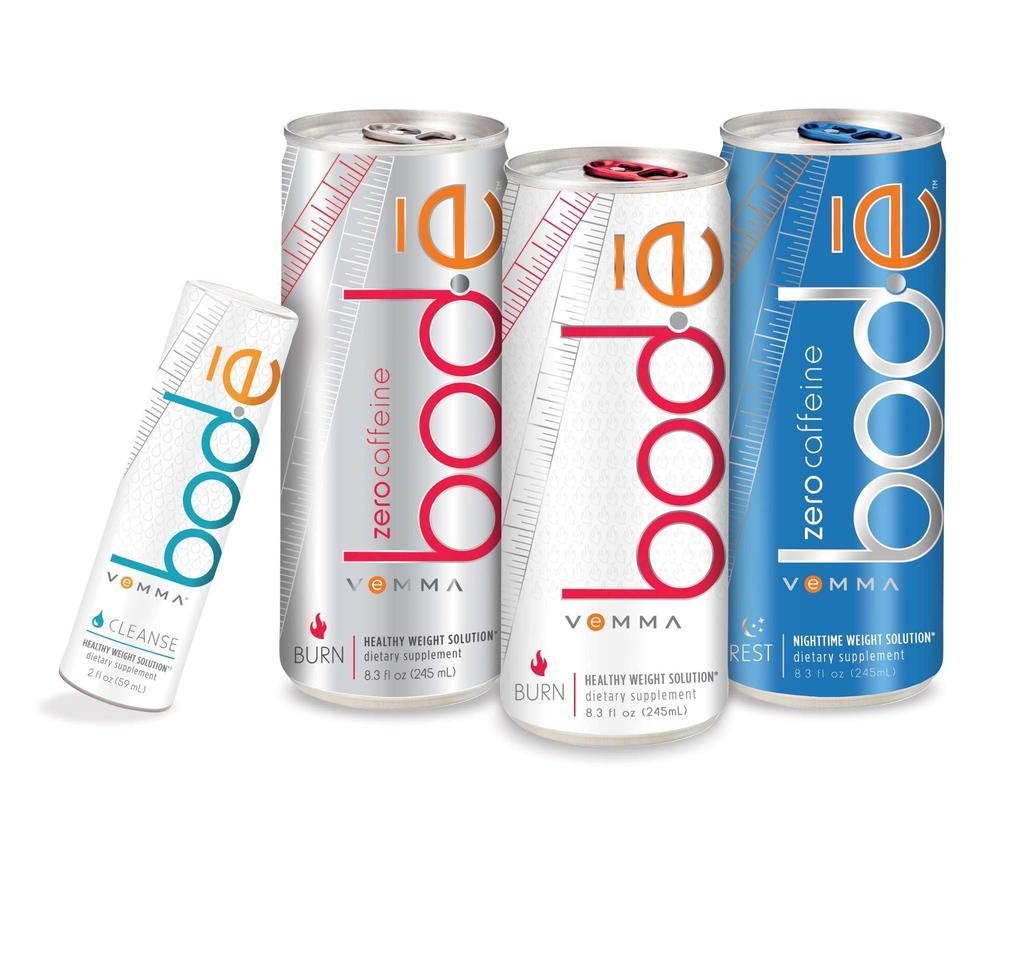<image>
Describe the image concisely. a bode can that is among other ones 